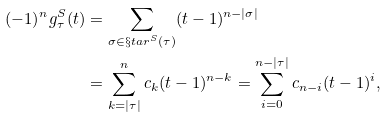Convert formula to latex. <formula><loc_0><loc_0><loc_500><loc_500>( - 1 ) ^ { n } g ^ { S } _ { \tau } ( t ) & = \sum _ { \sigma \in \S t a r ^ { S } ( \tau ) } ( t - 1 ) ^ { n - | \sigma | } \\ & = \sum _ { k = | \tau | } ^ { n } c _ { k } ( t - 1 ) ^ { n - k } = \sum _ { i = 0 } ^ { n - | \tau | } c _ { n - i } ( t - 1 ) ^ { i } ,</formula> 